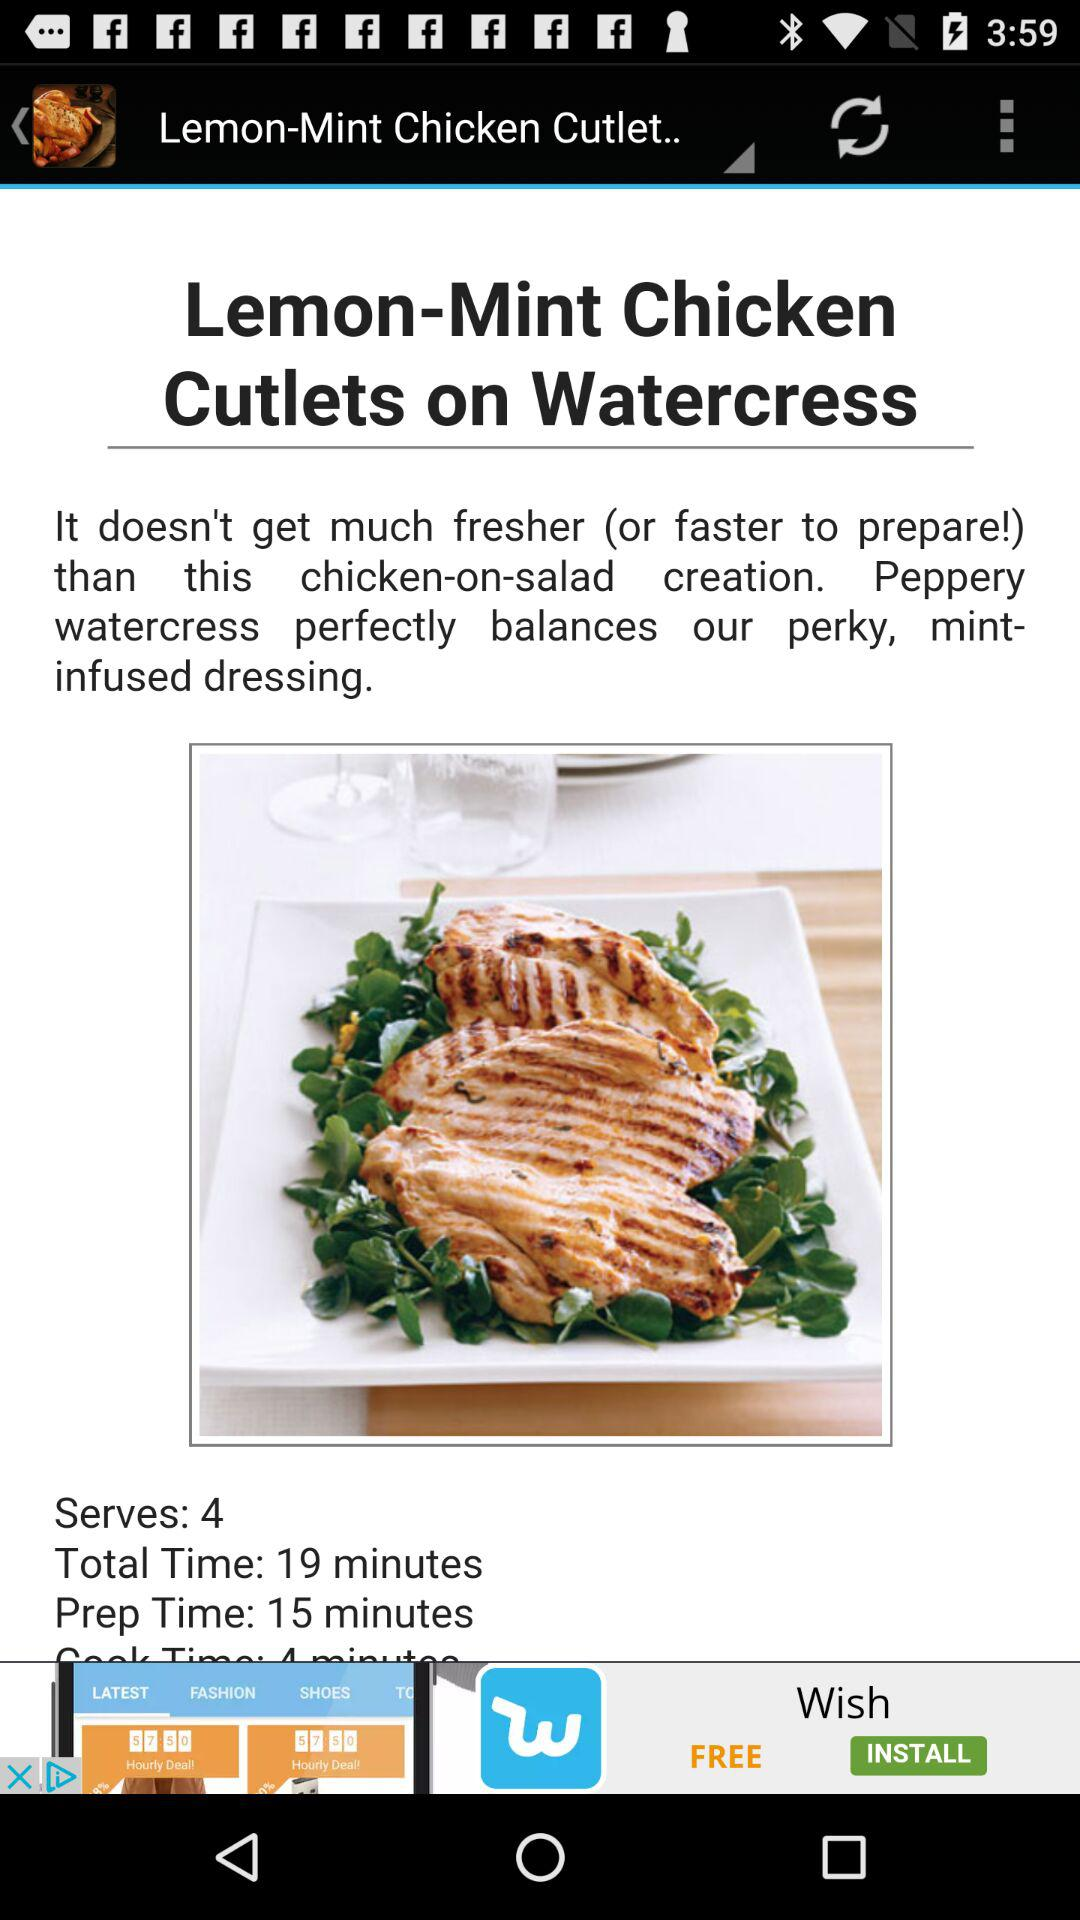What is the name of the dish? The name of the dish is "Lemon-Mint Chicken Cutlets on Watercress". 